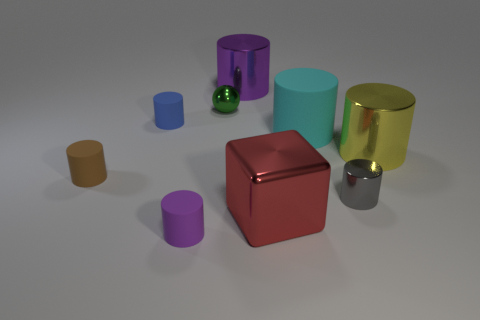Subtract all large purple metallic cylinders. How many cylinders are left? 6 Subtract all brown spheres. How many purple cylinders are left? 2 Subtract all spheres. How many objects are left? 8 Subtract 5 cylinders. How many cylinders are left? 2 Subtract all brown cylinders. How many cylinders are left? 6 Subtract 2 purple cylinders. How many objects are left? 7 Subtract all purple cylinders. Subtract all brown spheres. How many cylinders are left? 5 Subtract all tiny purple objects. Subtract all gray shiny objects. How many objects are left? 7 Add 1 blue rubber cylinders. How many blue rubber cylinders are left? 2 Add 6 big rubber things. How many big rubber things exist? 7 